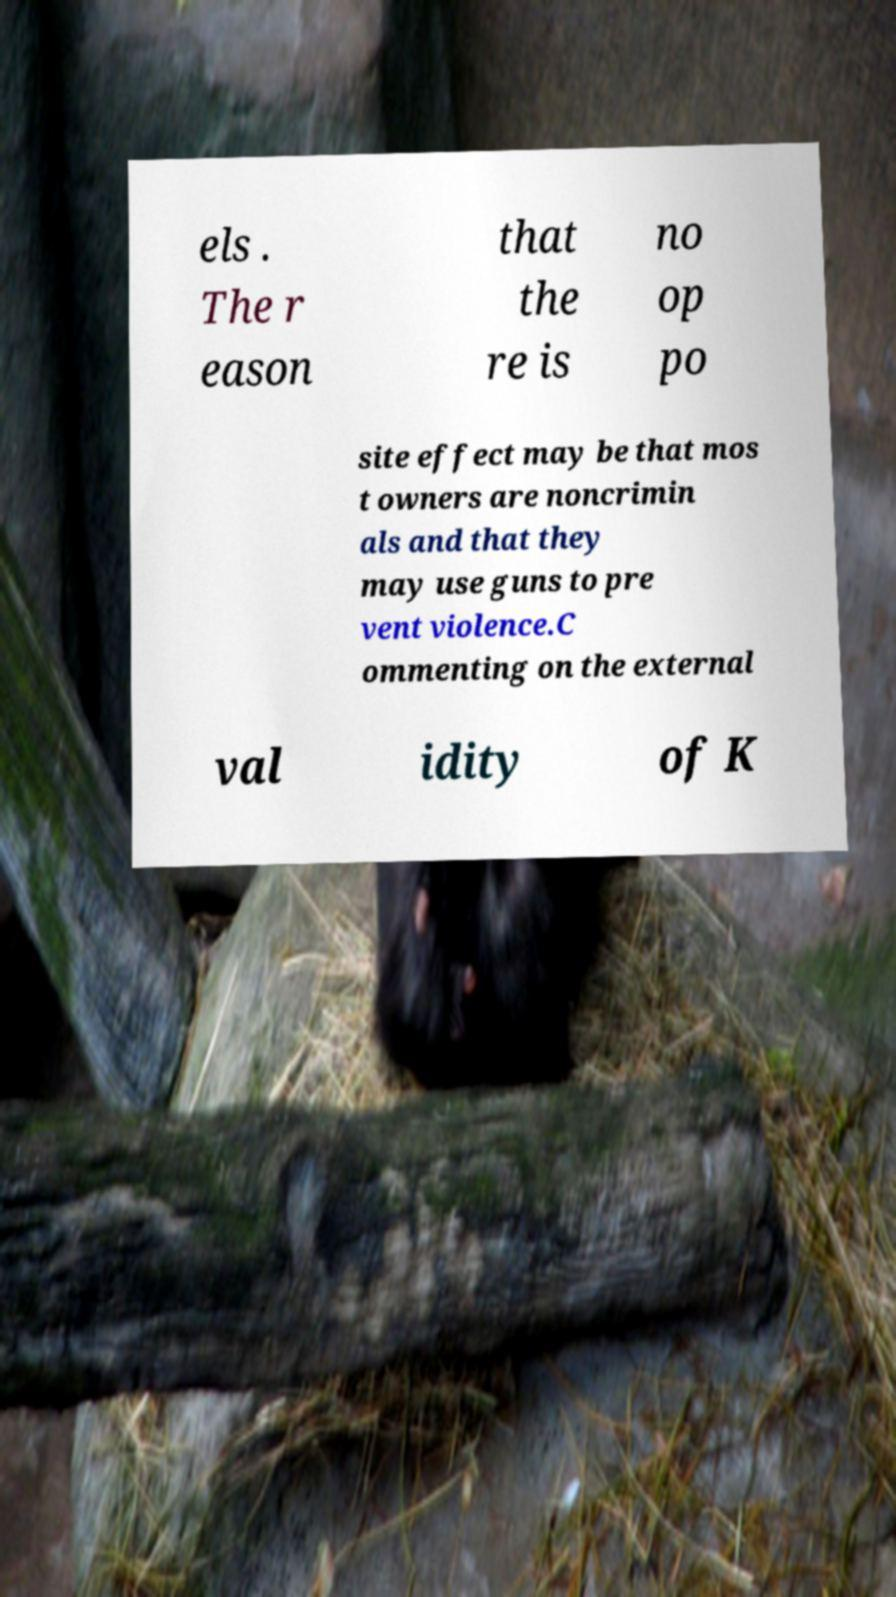Please identify and transcribe the text found in this image. els . The r eason that the re is no op po site effect may be that mos t owners are noncrimin als and that they may use guns to pre vent violence.C ommenting on the external val idity of K 